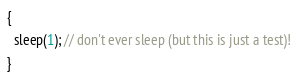Convert code to text. <code><loc_0><loc_0><loc_500><loc_500><_ObjectiveC_>{
  sleep(1); // don't ever sleep (but this is just a test)!
}
</code> 